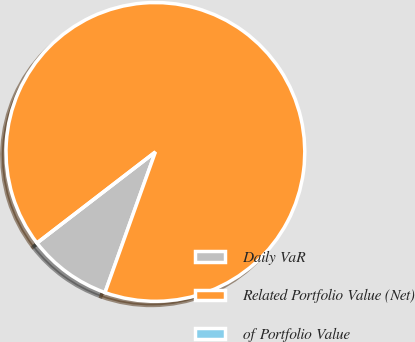Convert chart to OTSL. <chart><loc_0><loc_0><loc_500><loc_500><pie_chart><fcel>Daily VaR<fcel>Related Portfolio Value (Net)<fcel>of Portfolio Value<nl><fcel>9.09%<fcel>90.91%<fcel>0.0%<nl></chart> 